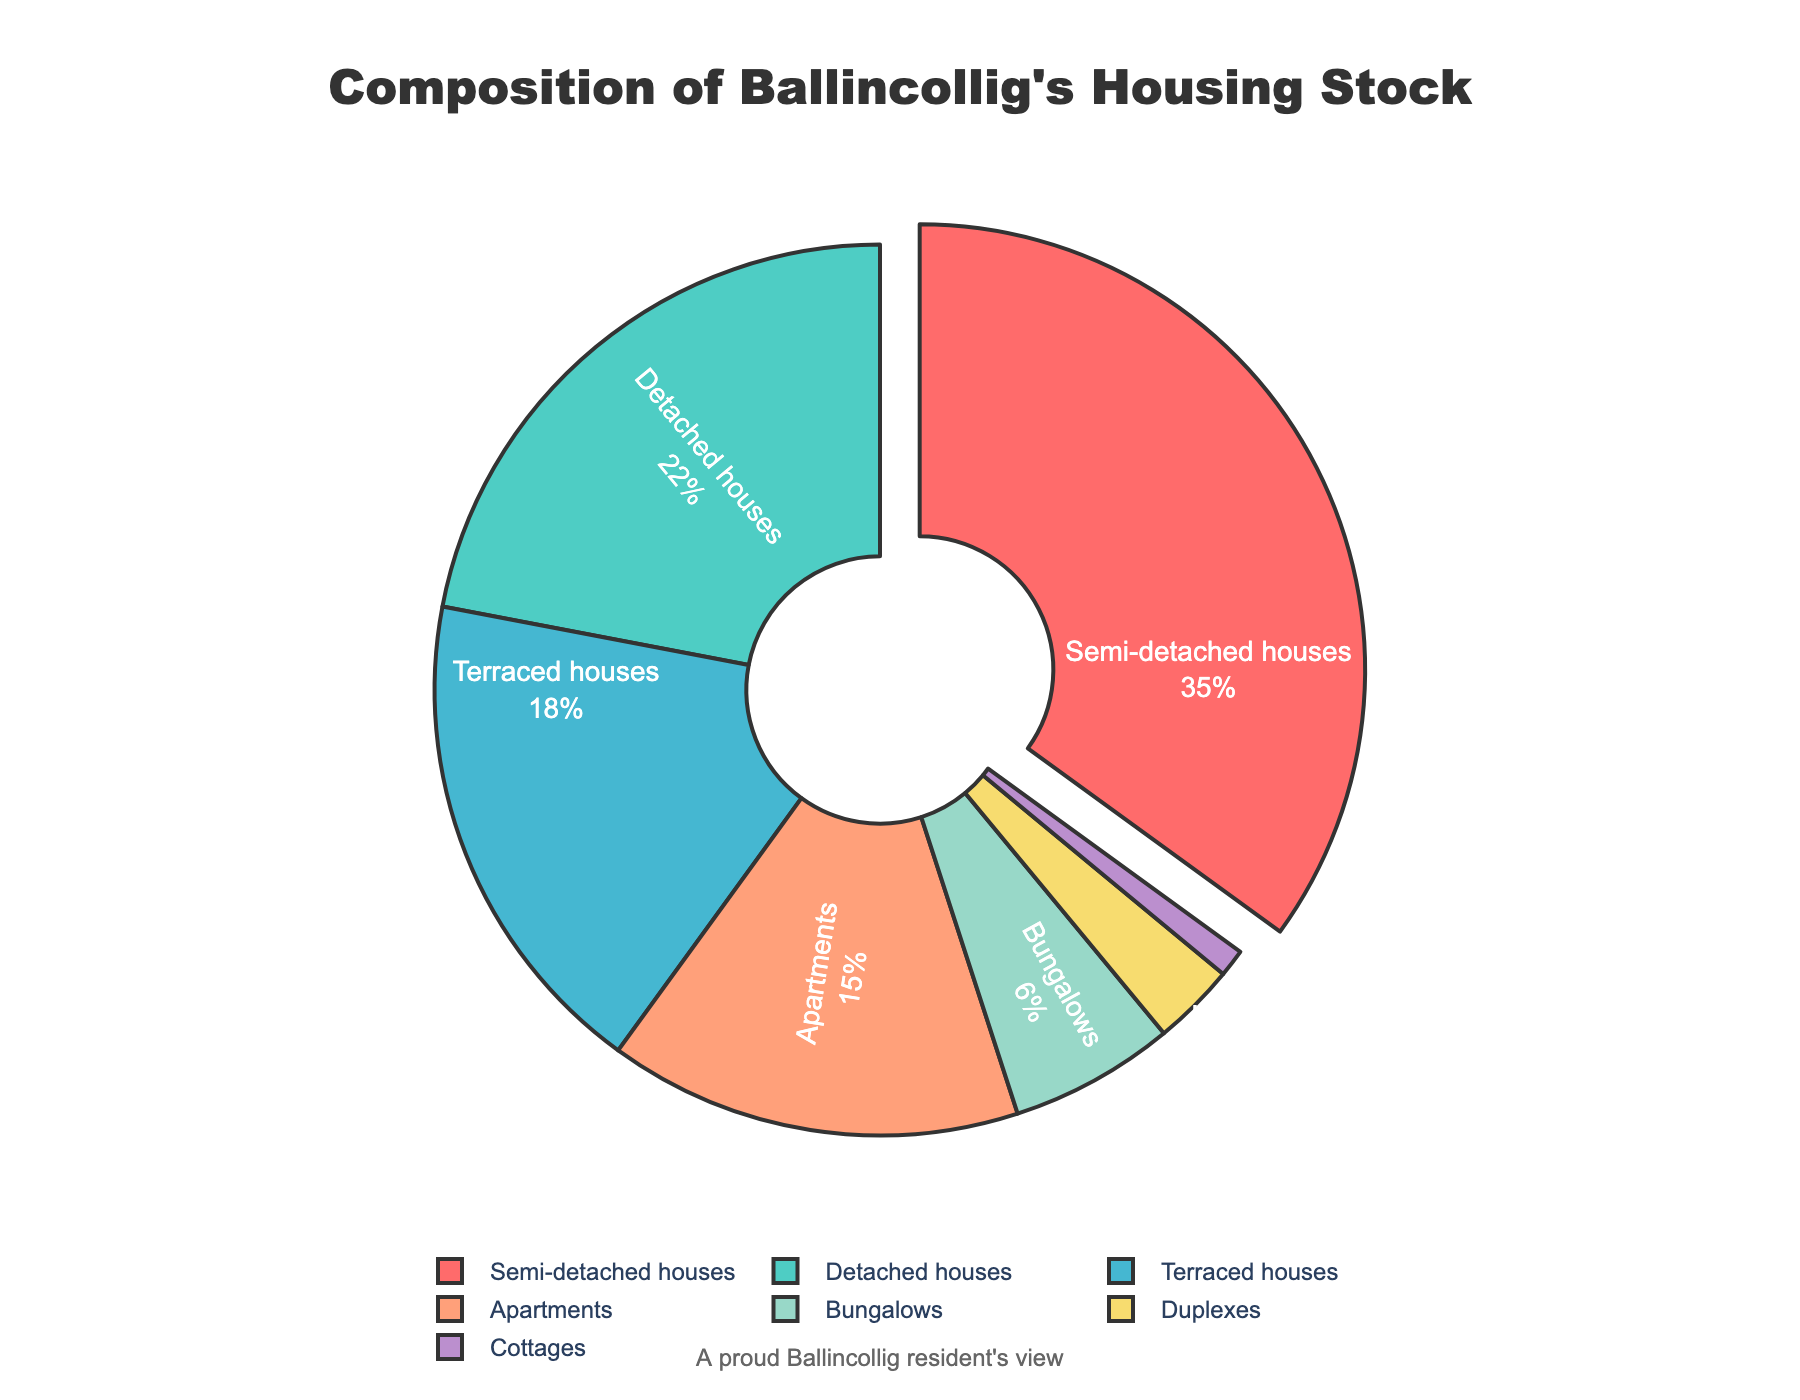What percentage of homes in Ballincollig are detached houses? The pie chart shows the percentage of homes that are detached houses, which is explicitly labeled.
Answer: 22% How many types of homes make up more than 10% each of the housing stock in Ballincollig? From the pie chart, the property types with percentages greater than 10% are semi-detached houses (35%), detached houses (22%), terraced houses (18%), and apartments (15%).
Answer: 4 By how much do semi-detached houses exceed terraced houses in terms of percentage? Subtract the percentage of terraced houses (18%) from the percentage of semi-detached houses (35%). The operation is 35% - 18% = 17%.
Answer: 17% If you combined the percentage of bungalows, duplexes, and cottages, what would be the total percentage? Add the percentages of bungalows (6%), duplexes (3%), and cottages (1%). The operation is 6% + 3% + 1% = 10%.
Answer: 10% Among all the property types shown, which type contributes the least to Ballincollig's housing stock? By observing the pie chart, cottages occupy the smallest segment, labeled as 1%.
Answer: Cottages Which property type segment is pulled out from the pie chart, and why? The pie chart design emphasizes the semi-detached houses segment by pulling it out, likely because it has the highest percentage (35%).
Answer: Semi-detached houses Is the combined percentage of detached houses and apartments greater than that of semi-detached houses? Add the percentages of detached houses (22%) and apartments (15%), which gives 22% + 15% = 37%. Then, compare it with the percentage of semi-detached houses (35%). Since 37% is greater than 35%, the combined percentage is indeed greater.
Answer: Yes What is the total percentage of housing stock represented by semi-detached and detached houses combined? Add the percentages of semi-detached houses (35%) and detached houses (22%), which gives 35% + 22% = 57%.
Answer: 57% Which property types are represented by shades of blue and green, and what are their respective percentages? From the pie chart, detached houses (22%) are in green, and terraced houses (18%) are in blue.
Answer: Detached houses (22%) and Terraced houses (18%) How does the percentage of bungalows compare to duplexes? Compare the percentages of bungalows (6%) and duplexes (3%). Observing, you'll see that bungalows have twice the percentage of duplexes.
Answer: Bungalows have twice the percentage of duplexes 